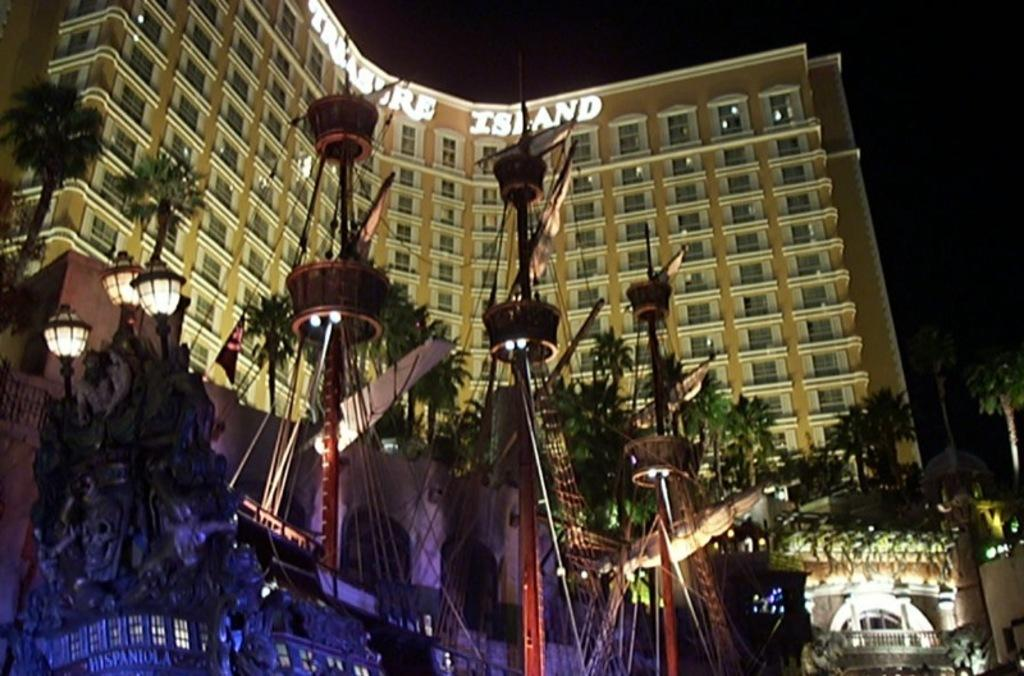What type of structure is visible in the image? There is a building in the image. What is the other prominent object in the image? There is a ship in the image. What type of natural elements can be seen in the image? There are trees and plants in the image. What is written or displayed on a board in the image? There is a board with text in the image. How would you describe the overall lighting or brightness of the image? The background of the image is dark. Can you tell me how many firemen are visible in the image? There are no firemen present in the image. What type of prison can be seen in the image? There is no prison present in the image. 